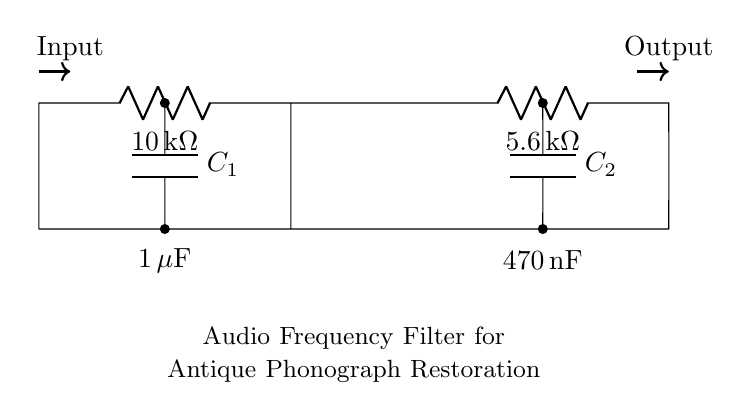What is the value of R1? R1 is labeled as 10kΩ in the circuit diagram.
Answer: 10 kΩ What type of components are C1 and C2? C1 and C2 are capacitors, which are shown in the circuit as C with their respective labels.
Answer: Capacitors What is the purpose of the resistors in this circuit? The resistors limit current and contribute to filter characteristics by determining the cut-off frequency in conjunction with the capacitors.
Answer: Current limiting and filtering What is the capacitance of C1? C1 is labeled with a capacitance value of 1 microfarad, as denoted in the circuit diagram.
Answer: 1 microfarad What happens to the cut-off frequency if R1 is increased? Increasing R1 raises the overall resistance, which increases the cut-off frequency of the filter circuit.
Answer: Increases cut-off frequency What is the total resistance in the path after R2? The total resistance in the path after R2 includes R1 and R2 in series, which adds up to 15.6kΩ.
Answer: 15.6 kΩ How are C1 and C2 connected in the circuit? C1 and C2 are in parallel to each other, as indicated by their connections to a common node.
Answer: In parallel 